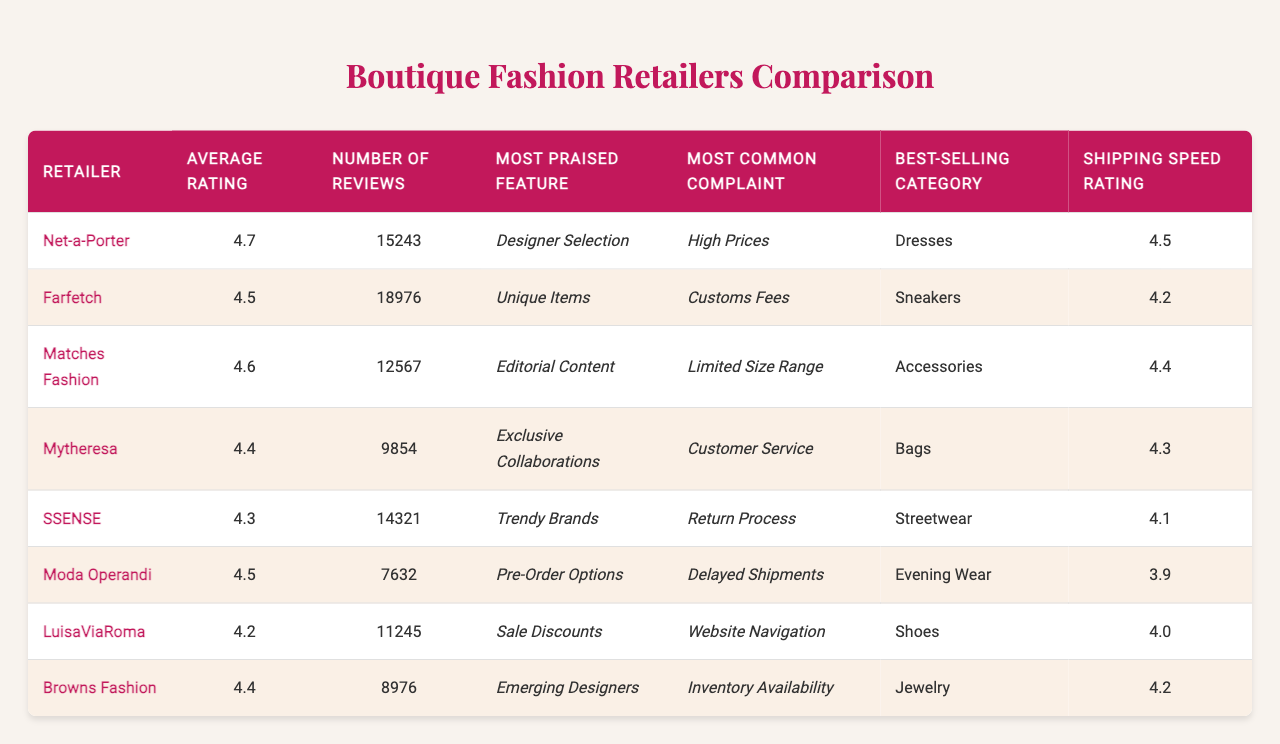What is the average rating of Farfetch? The average rating for Farfetch is listed directly in the table as 4.5.
Answer: 4.5 Which retailer has the most reviews? The retailer with the most reviews is Farfetch, which has 18,976 reviews, as seen in the "Number of Reviews" column.
Answer: Farfetch What is the best-selling category for Net-a-Porter? The best-selling category for Net-a-Porter, according to the table, is Dresses.
Answer: Dresses Is the most praised feature for Mytheresa's exclusive collaborations? Yes, according to the table, the most praised feature for Mytheresa is indeed exclusive collaborations.
Answer: Yes Which retailer has the highest shipping speed rating? Net-a-Porter has the highest shipping speed rating of 4.5, based on the information in the last column of the table.
Answer: Net-a-Porter What is the difference in average rating between Mytheresa and SSENSE? Mytheresa has an average rating of 4.4, while SSENSE has 4.3. The difference is 4.4 - 4.3 = 0.1.
Answer: 0.1 How many reviews does Browns Fashion have compared to Moda Operandi? Browns Fashion has 8,976 reviews, whereas Moda Operandi has 7,632 reviews. The difference in the number of reviews is 8,976 - 7,632 = 1,344, which means Browns Fashion has more reviews.
Answer: 1,344 Which retailer has the lowest average rating and what is it? LuisaViaRoma has the lowest average rating at 4.2, as it is the smallest value in the "Average Rating" column of the table.
Answer: 4.2 Which retailer has a complaint about high prices, and what is its average rating? The retailer with a complaint about high prices is Net-a-Porter, which has an average rating of 4.7.
Answer: 4.7 How many total reviews are there for all retailers combined? To find the total, sum the number of reviews for each retailer: 15,243 + 18,976 + 12,567 + 9,854 + 14,321 + 7,632 + 11,245 + 8,976 = 99,814.
Answer: 99,814 